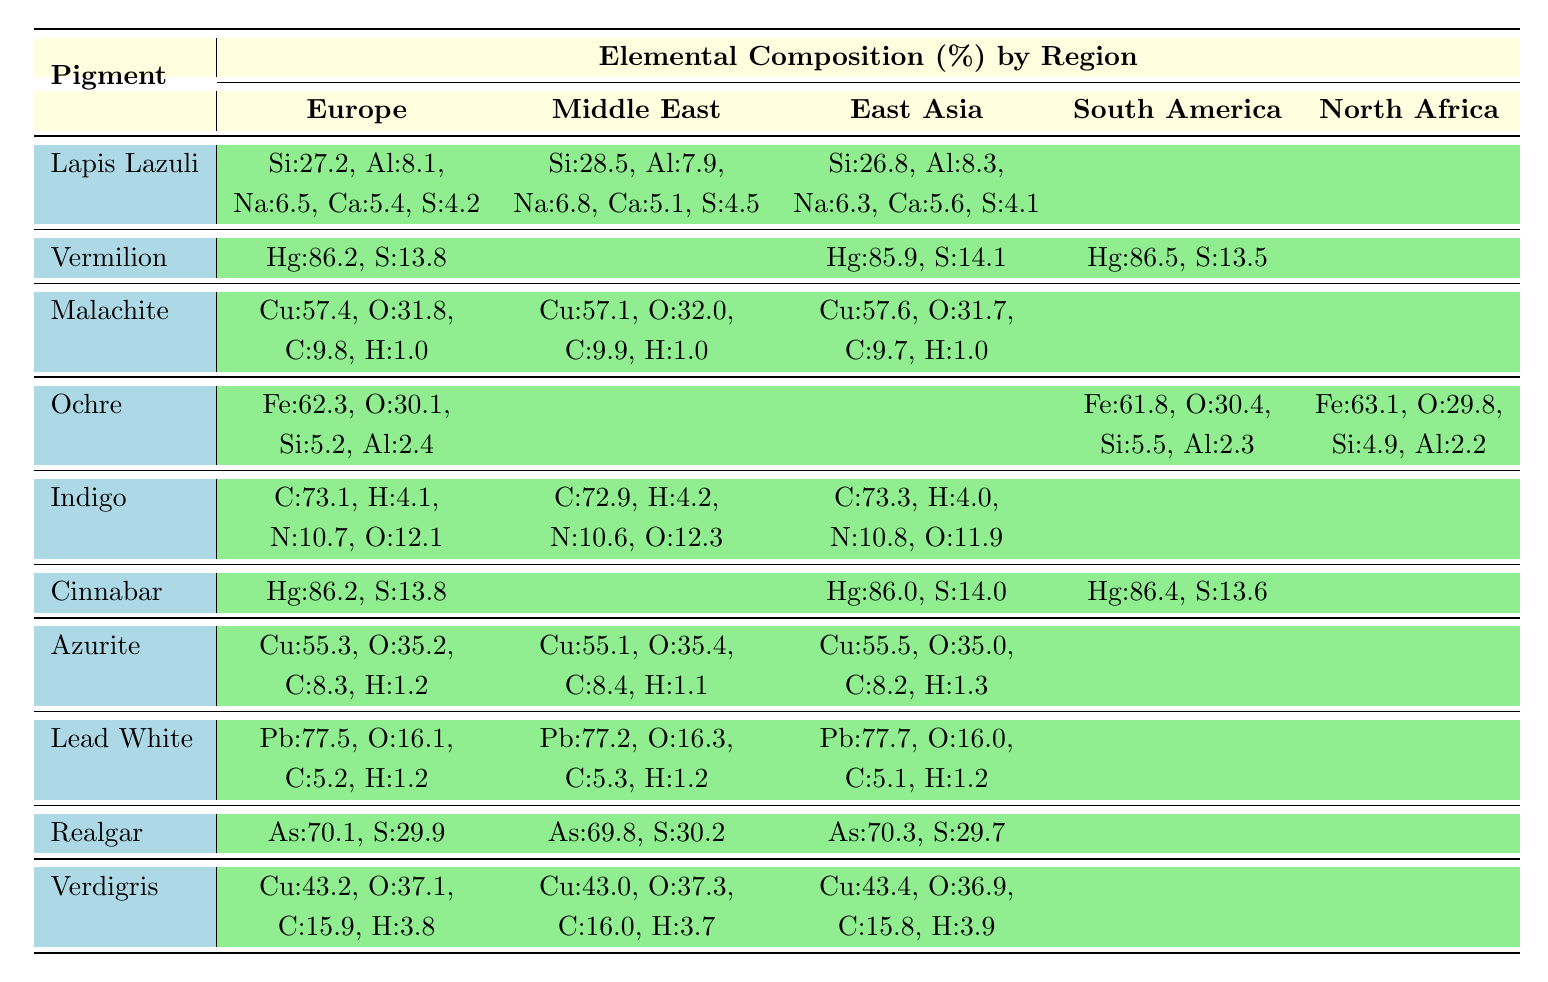What is the elemental composition of Lapis Lazuli from Europe? From the table, the composition of Lapis Lazuli from Europe is listed as Si:27.2, Al:8.1, Na:6.5, Ca:5.4, and S:4.2.
Answer: Si:27.2, Al:8.1, Na:6.5, Ca:5.4, S:4.2 Which pigment has the highest mercury content in South America? According to the table, the mercury content for Vermilion in South America is 86.5, while Cinnabar has 86.4. Hence, Vermilion has the highest mercury content.
Answer: Vermilion What is the average copper content in Malachite across all reported regions? The copper content for Malachite is 57.4 (Europe), 57.1 (Middle East), and 57.6 (East Asia). To find the average, sum these values: 57.4 + 57.1 + 57.6 = 172.1, then divide by 3 to get 172.1/3 ≈ 57.37.
Answer: 57.37 Does Azurite contain any elements in the South American region? The table shows no data listed for Azurite in South America, indicating that Azurite does not have a reported elemental composition in that region.
Answer: No What element makes up the highest percentage in Ochre from Europe? From the data, Ochre's highest elemental composition in Europe is Fe at 62.3, with the other components being significantly lower.
Answer: Fe What is the total percentage of elements for Verdigris from East Asia? For Verdigris from East Asia, the elemental composition is Cu:43.4, O:36.9, C:15.8, H:3.9. Summing these values gives: 43.4 + 36.9 + 15.8 + 3.9 = 100.0, indicating it fully accounts for 100%.
Answer: 100.0 Which pigment has a higher average sulfur content, Vermilion or Cinnabar? The average sulfur content in Vermilion (13.8 in Europe, 14.1 in East Asia, and 13.5 in South America) is (13.8 + 14.1 + 13.5) / 3 = 13.8. Cinnabar's sulfur content is (13.8 in Europe, 14.0 in East Asia, and 13.6 in South America) averaging to (13.8 + 14.0 + 13.6) / 3 = 13.8. Both pigments have the same average sulfur content.
Answer: They are equal Is Si present in the elemental composition of Indigo? The table does not list Si (Silicon) as a component of Indigo; it only shows C, H, N, and O present in its composition.
Answer: No What is the difference between the lead content in Lead White from Europe and East Asia? The lead content in Europe is 77.5, while in East Asia it is 77.7. Thus, the difference is 77.7 - 77.5 = 0.2.
Answer: 0.2 Which region shows the highest proportion of As (Arsenic) in Realgar? The table indicates that the As content in Europe is 70.1, in the Middle East it is 69.8, and in East Asia it is 70.3. Therefore, East Asia shows the highest proportion of As in Realgar.
Answer: East Asia 